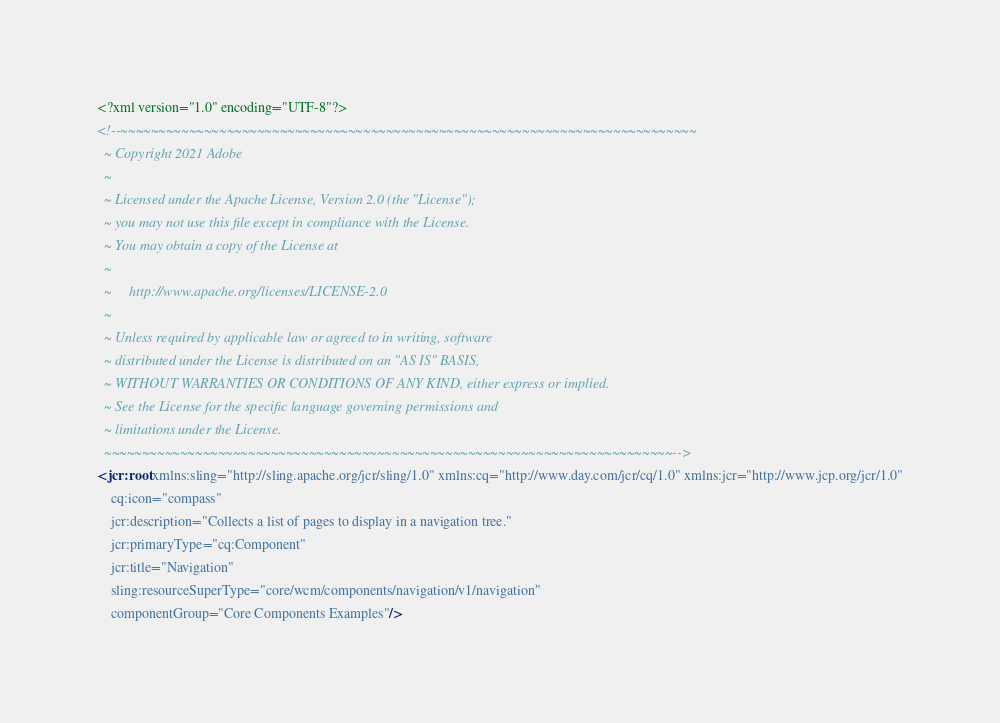<code> <loc_0><loc_0><loc_500><loc_500><_XML_><?xml version="1.0" encoding="UTF-8"?>
<!--~~~~~~~~~~~~~~~~~~~~~~~~~~~~~~~~~~~~~~~~~~~~~~~~~~~~~~~~~~~~~~~~~~~~~~~~~~~~
  ~ Copyright 2021 Adobe
  ~
  ~ Licensed under the Apache License, Version 2.0 (the "License");
  ~ you may not use this file except in compliance with the License.
  ~ You may obtain a copy of the License at
  ~
  ~     http://www.apache.org/licenses/LICENSE-2.0
  ~
  ~ Unless required by applicable law or agreed to in writing, software
  ~ distributed under the License is distributed on an "AS IS" BASIS,
  ~ WITHOUT WARRANTIES OR CONDITIONS OF ANY KIND, either express or implied.
  ~ See the License for the specific language governing permissions and
  ~ limitations under the License.
  ~~~~~~~~~~~~~~~~~~~~~~~~~~~~~~~~~~~~~~~~~~~~~~~~~~~~~~~~~~~~~~~~~~~~~~~~~~~-->
<jcr:root xmlns:sling="http://sling.apache.org/jcr/sling/1.0" xmlns:cq="http://www.day.com/jcr/cq/1.0" xmlns:jcr="http://www.jcp.org/jcr/1.0"
    cq:icon="compass"
    jcr:description="Collects a list of pages to display in a navigation tree."
    jcr:primaryType="cq:Component"
    jcr:title="Navigation"
    sling:resourceSuperType="core/wcm/components/navigation/v1/navigation"
    componentGroup="Core Components Examples"/>
</code> 